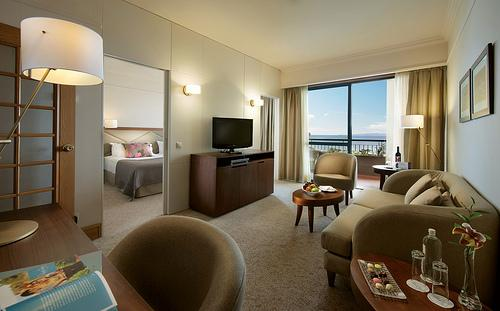List two items that may suggest this is a cosy and comfortable living space. A brown couch with pillows and a wooden coffee table suggest this is a cosy and comfortable living space. What can be seen through the windows in the image? A scenic view with a clear blue sky can be seen through the windows. Are there any decorative features on the wall, and if so, what are they? Yes, there are wall hangings, small lit wall fixture lights, and two framed objects on the wall. Describe the floral object present in the room and its container. There is a single lily flower in a clear glass vase in the room. Identify the type of room where the objects are located. The objects are located in a living room or a common area of a house. What's unique about the magazine in the image, and where is it located? The unique thing about the magazine is that it is open, showing a photo of a family, and it's located on a table. What's the state of the door in the room, and what color is the chair near the coffee table? The door in the room is closed, and the chair near the coffee table is tan. Describe any sources of light present in the room. There is a lit white table lamp in the room and small lit wall fixture lights on the wall. Mention three furniture items present in the image. There are a brown couch, a wooden table, and a brown seat in the image. What are the objects on the television stand? There is a black flat-screen television and a TV cabinet on the television stand. List the items placed on the coffee table in the room. A bowl of assorted fruits can be found on the coffee table. What color is the couch in the image, and does it have any pillows? The couch is brown and has pillows. What is the state of the door in the room: open, closed, or not visible? The door is closed. What is the color of the chair in the image? The chair is tan. Is the couch blue and covered with a blanket? The couch is actually brown and there is no mention of a blanket on it. What type of device is found in the room displaying a scenic view? A flat screen television displays the scenic view. Confirm the presence or absence of the following items in the scene: a) a bed; b) a floor lamp; c) a fruit bowl. a) A bed is present in the other room; b) There is a floor lamp in the scene; c) A fruit bowl is present on the wooden table. How many people are visible in the open magazine? There is a photo of a family in the open magazine. There is a magazine in the picture. Describe its placement and appearance. The open magazine is on a table, displaying a photo of a family. What is the atmosphere like outside the window? The sky outside is blue and clear. Describe the scene with a focus on the vase and flower arrangement. There is a glass vase with a single lily in it on a wooden table, surrounded by assorted candies and a clear bottle of water with an empty glass. Are the curtains red and white striped? The curtains are described as tan and cream, not red and white striped. Is the television in the room on or off? The television is off. Describe the window covers in the image. The window covers are tan and cream colored. Is the magazine on the wooden table closed? The magazine is described as open and is not mentioned to be on the wooden table. Can you see a dog on the floor? There is no mention of a dog in the image. Choose the correct statement about the appearance of the wall hangings: A) They are framed; B) They are not framed; C) There are no wall hangings. A) They are framed. What objects are found together in the scene near the vase? A tray of assorted candies, a clear bottle of water, and an empty glass. What is the color and design of the pillow on the bed? The pillow has a pink and brown floral design. What type of lighting fixtures are present in the room? There are lit white table lamps and small lit wall fixture lights. Which object is placed next to the brown couch: a chair, a coffee table, or a side table?  A small side table is placed beside the brown couch. Describe the appearance of the television in the room. It is a black flat screen television monitor placed on a cabinet. Is there a bowl of soup near the flower in the vase? There is no mention of a bowl of soup in the image. Is the television turned on and showing a movie? The television is described as off and there is no mention of a movie being shown. 